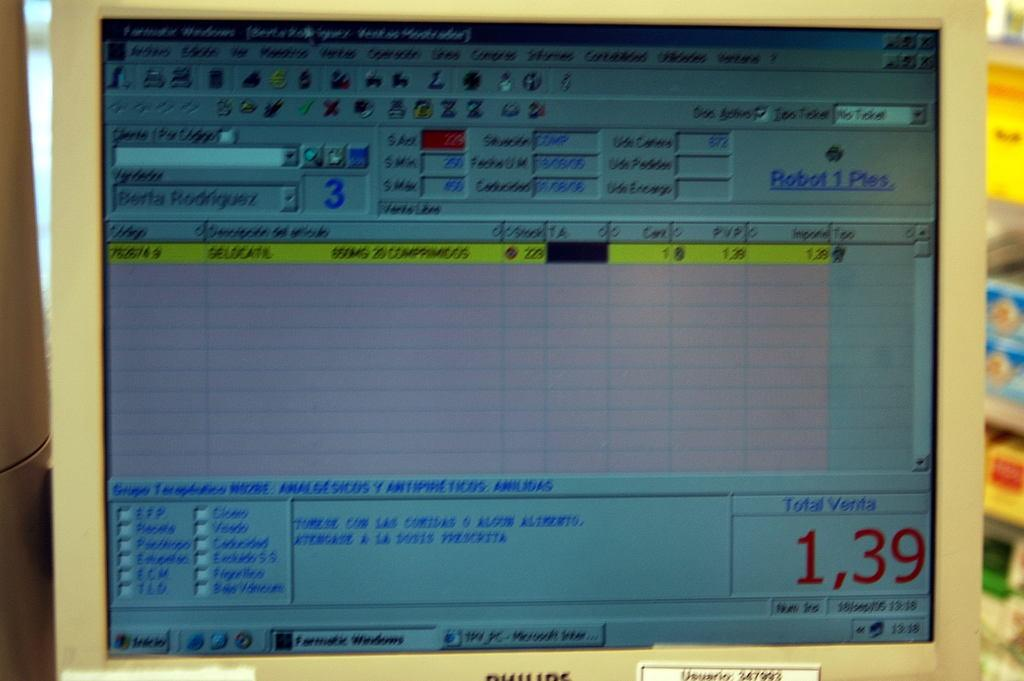<image>
Summarize the visual content of the image. A computer monitor that displays a Total Venta of 1,39 